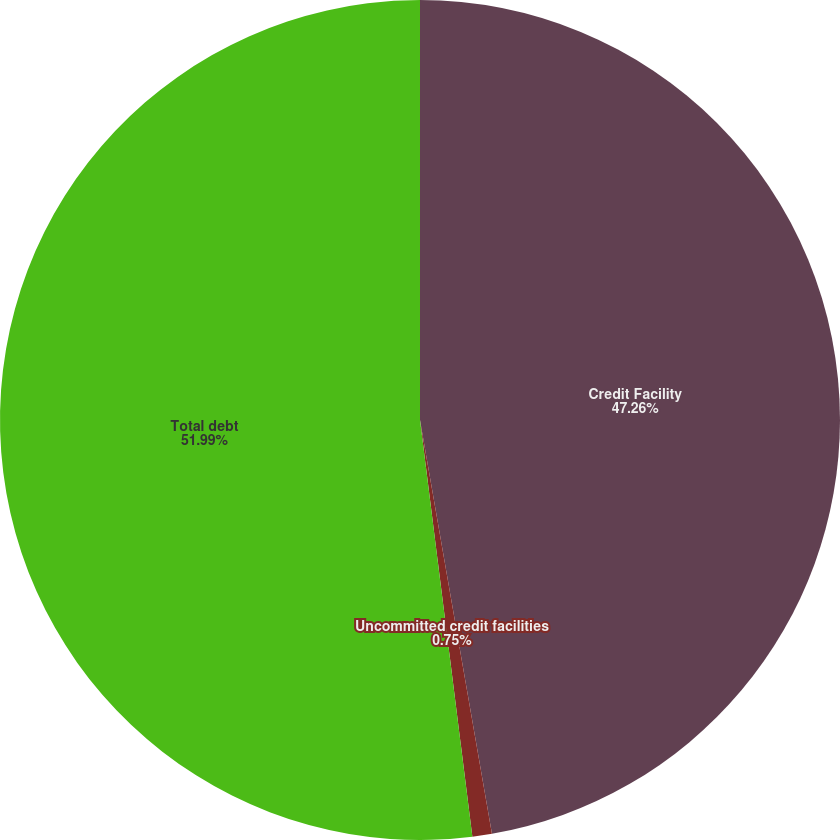Convert chart to OTSL. <chart><loc_0><loc_0><loc_500><loc_500><pie_chart><fcel>Credit Facility<fcel>Uncommitted credit facilities<fcel>Total debt<nl><fcel>47.26%<fcel>0.75%<fcel>51.99%<nl></chart> 